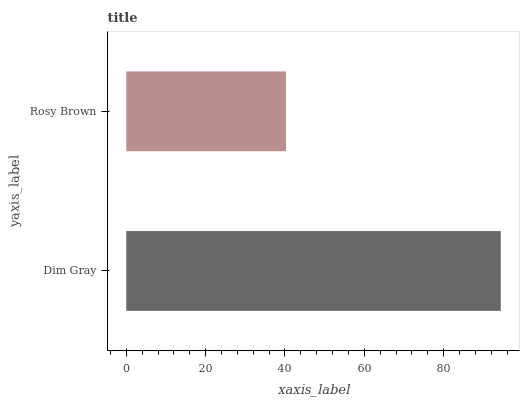Is Rosy Brown the minimum?
Answer yes or no. Yes. Is Dim Gray the maximum?
Answer yes or no. Yes. Is Rosy Brown the maximum?
Answer yes or no. No. Is Dim Gray greater than Rosy Brown?
Answer yes or no. Yes. Is Rosy Brown less than Dim Gray?
Answer yes or no. Yes. Is Rosy Brown greater than Dim Gray?
Answer yes or no. No. Is Dim Gray less than Rosy Brown?
Answer yes or no. No. Is Dim Gray the high median?
Answer yes or no. Yes. Is Rosy Brown the low median?
Answer yes or no. Yes. Is Rosy Brown the high median?
Answer yes or no. No. Is Dim Gray the low median?
Answer yes or no. No. 